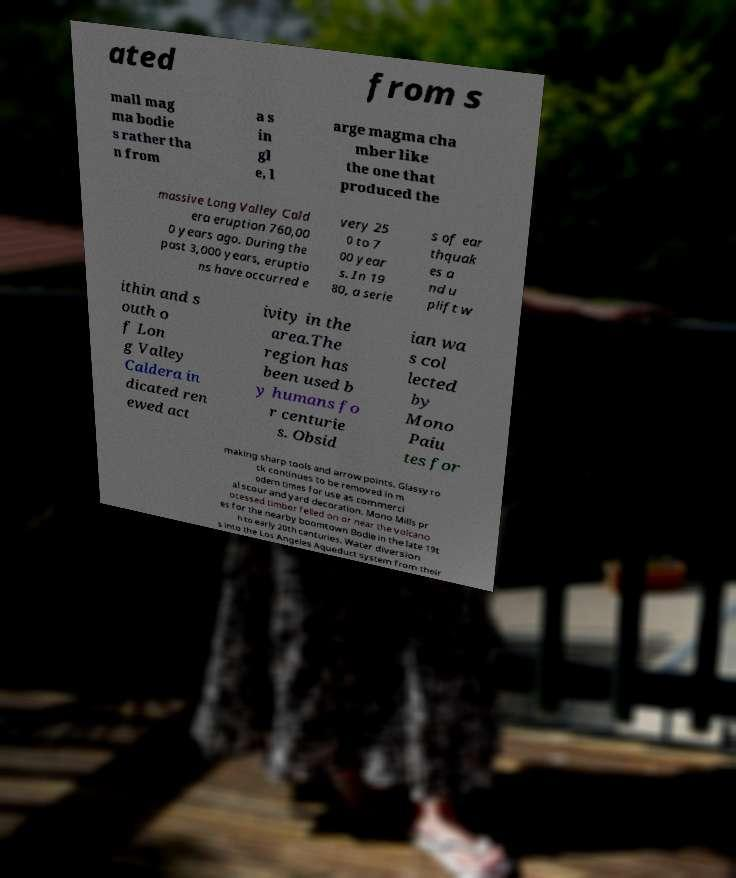Please read and relay the text visible in this image. What does it say? ated from s mall mag ma bodie s rather tha n from a s in gl e, l arge magma cha mber like the one that produced the massive Long Valley Cald era eruption 760,00 0 years ago. During the past 3,000 years, eruptio ns have occurred e very 25 0 to 7 00 year s. In 19 80, a serie s of ear thquak es a nd u plift w ithin and s outh o f Lon g Valley Caldera in dicated ren ewed act ivity in the area.The region has been used b y humans fo r centurie s. Obsid ian wa s col lected by Mono Paiu tes for making sharp tools and arrow points. Glassy ro ck continues to be removed in m odern times for use as commerci al scour and yard decoration. Mono Mills pr ocessed timber felled on or near the volcano es for the nearby boomtown Bodie in the late 19t h to early 20th centuries. Water diversion s into the Los Angeles Aqueduct system from their 